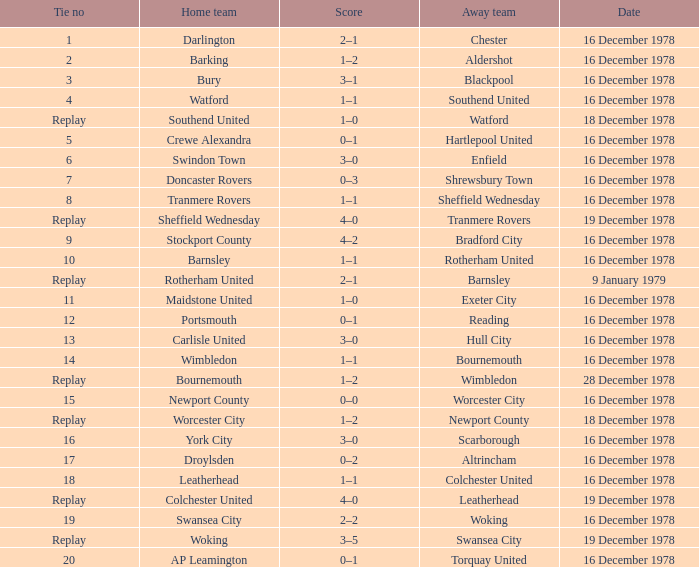Waht was the away team when the home team is colchester united? Leatherhead. 